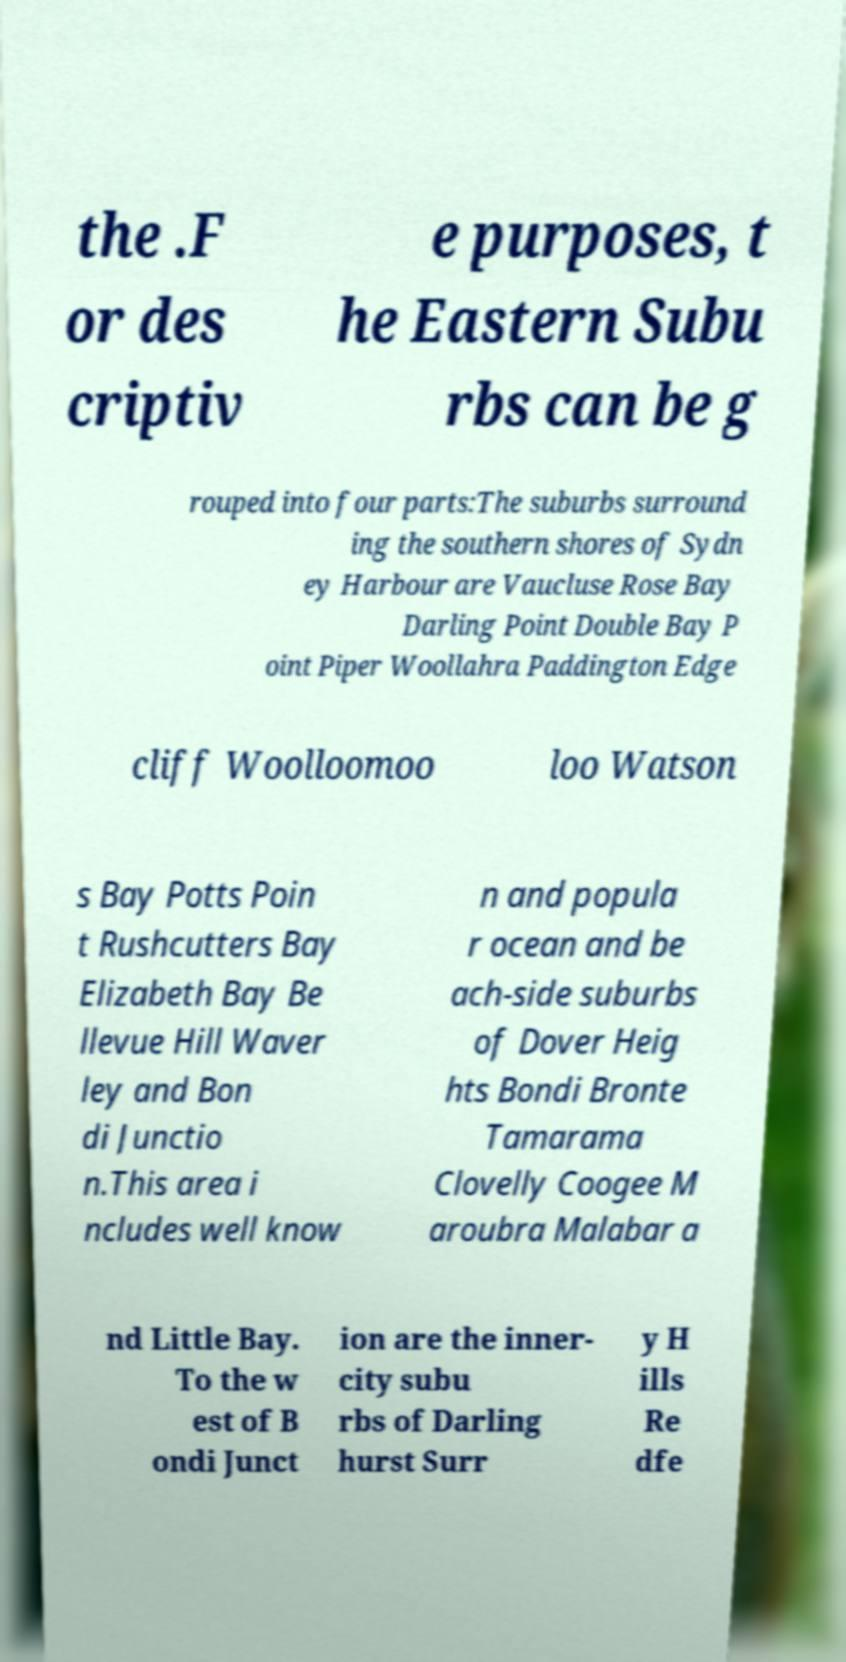Can you accurately transcribe the text from the provided image for me? the .F or des criptiv e purposes, t he Eastern Subu rbs can be g rouped into four parts:The suburbs surround ing the southern shores of Sydn ey Harbour are Vaucluse Rose Bay Darling Point Double Bay P oint Piper Woollahra Paddington Edge cliff Woolloomoo loo Watson s Bay Potts Poin t Rushcutters Bay Elizabeth Bay Be llevue Hill Waver ley and Bon di Junctio n.This area i ncludes well know n and popula r ocean and be ach-side suburbs of Dover Heig hts Bondi Bronte Tamarama Clovelly Coogee M aroubra Malabar a nd Little Bay. To the w est of B ondi Junct ion are the inner- city subu rbs of Darling hurst Surr y H ills Re dfe 